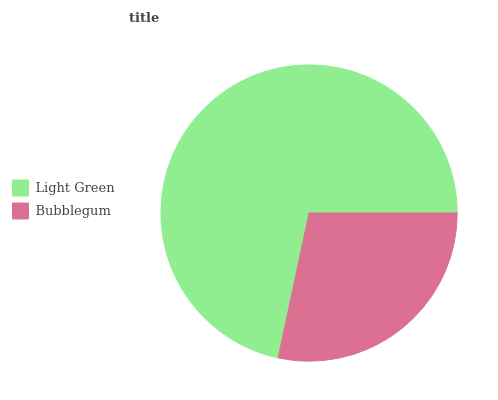Is Bubblegum the minimum?
Answer yes or no. Yes. Is Light Green the maximum?
Answer yes or no. Yes. Is Bubblegum the maximum?
Answer yes or no. No. Is Light Green greater than Bubblegum?
Answer yes or no. Yes. Is Bubblegum less than Light Green?
Answer yes or no. Yes. Is Bubblegum greater than Light Green?
Answer yes or no. No. Is Light Green less than Bubblegum?
Answer yes or no. No. Is Light Green the high median?
Answer yes or no. Yes. Is Bubblegum the low median?
Answer yes or no. Yes. Is Bubblegum the high median?
Answer yes or no. No. Is Light Green the low median?
Answer yes or no. No. 